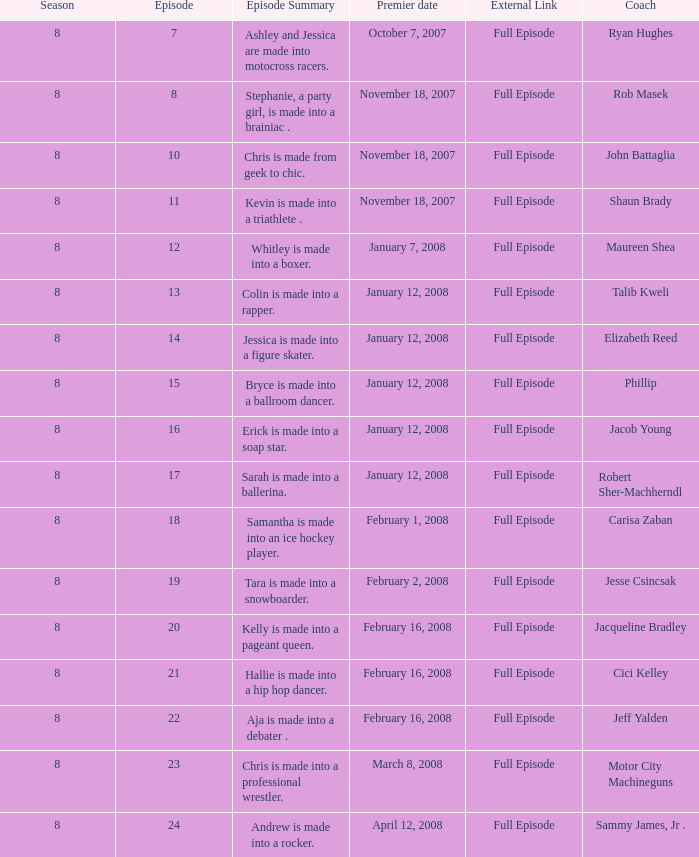In which season did cici kelley achieve the lowest performance? 8.0. Give me the full table as a dictionary. {'header': ['Season', 'Episode', 'Episode Summary', 'Premier date', 'External Link', 'Coach'], 'rows': [['8', '7', 'Ashley and Jessica are made into motocross racers.', 'October 7, 2007', 'Full Episode', 'Ryan Hughes'], ['8', '8', 'Stephanie, a party girl, is made into a brainiac .', 'November 18, 2007', 'Full Episode', 'Rob Masek'], ['8', '10', 'Chris is made from geek to chic.', 'November 18, 2007', 'Full Episode', 'John Battaglia'], ['8', '11', 'Kevin is made into a triathlete .', 'November 18, 2007', 'Full Episode', 'Shaun Brady'], ['8', '12', 'Whitley is made into a boxer.', 'January 7, 2008', 'Full Episode', 'Maureen Shea'], ['8', '13', 'Colin is made into a rapper.', 'January 12, 2008', 'Full Episode', 'Talib Kweli'], ['8', '14', 'Jessica is made into a figure skater.', 'January 12, 2008', 'Full Episode', 'Elizabeth Reed'], ['8', '15', 'Bryce is made into a ballroom dancer.', 'January 12, 2008', 'Full Episode', 'Phillip'], ['8', '16', 'Erick is made into a soap star.', 'January 12, 2008', 'Full Episode', 'Jacob Young'], ['8', '17', 'Sarah is made into a ballerina.', 'January 12, 2008', 'Full Episode', 'Robert Sher-Machherndl'], ['8', '18', 'Samantha is made into an ice hockey player.', 'February 1, 2008', 'Full Episode', 'Carisa Zaban'], ['8', '19', 'Tara is made into a snowboarder.', 'February 2, 2008', 'Full Episode', 'Jesse Csincsak'], ['8', '20', 'Kelly is made into a pageant queen.', 'February 16, 2008', 'Full Episode', 'Jacqueline Bradley'], ['8', '21', 'Hallie is made into a hip hop dancer.', 'February 16, 2008', 'Full Episode', 'Cici Kelley'], ['8', '22', 'Aja is made into a debater .', 'February 16, 2008', 'Full Episode', 'Jeff Yalden'], ['8', '23', 'Chris is made into a professional wrestler.', 'March 8, 2008', 'Full Episode', 'Motor City Machineguns'], ['8', '24', 'Andrew is made into a rocker.', 'April 12, 2008', 'Full Episode', 'Sammy James, Jr .']]} 